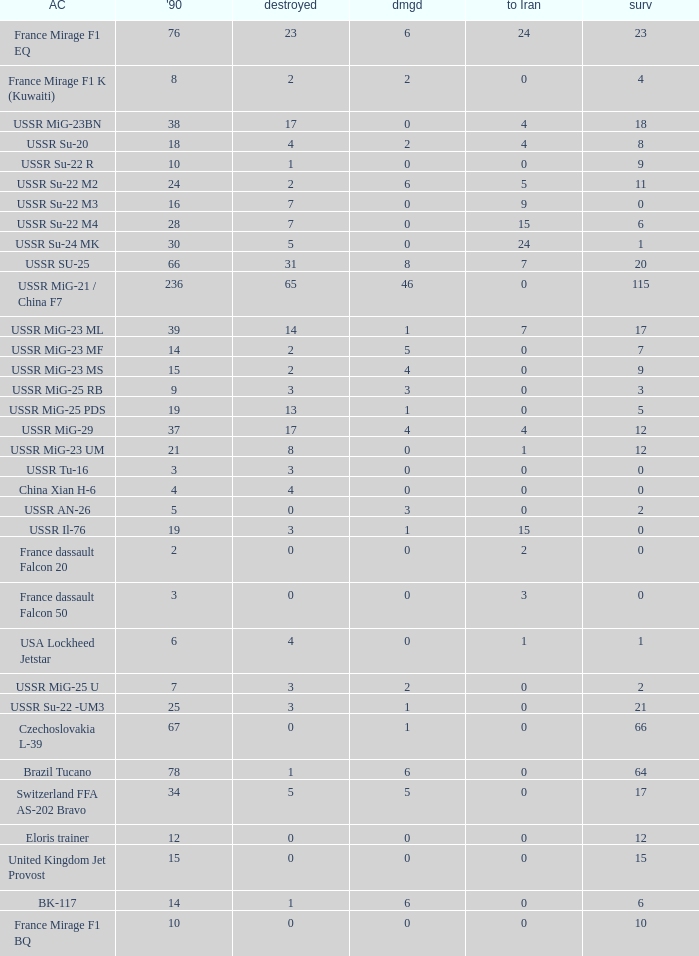If the aircraft was  ussr mig-25 rb how many were destroyed? 3.0. 